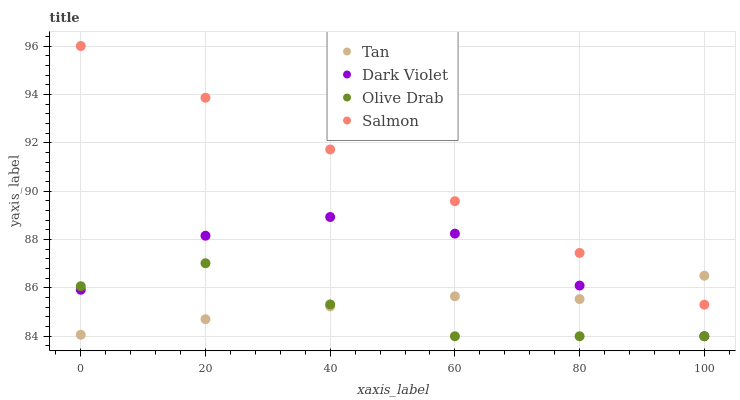Does Olive Drab have the minimum area under the curve?
Answer yes or no. Yes. Does Salmon have the maximum area under the curve?
Answer yes or no. Yes. Does Salmon have the minimum area under the curve?
Answer yes or no. No. Does Olive Drab have the maximum area under the curve?
Answer yes or no. No. Is Salmon the smoothest?
Answer yes or no. Yes. Is Dark Violet the roughest?
Answer yes or no. Yes. Is Olive Drab the smoothest?
Answer yes or no. No. Is Olive Drab the roughest?
Answer yes or no. No. Does Olive Drab have the lowest value?
Answer yes or no. Yes. Does Salmon have the lowest value?
Answer yes or no. No. Does Salmon have the highest value?
Answer yes or no. Yes. Does Olive Drab have the highest value?
Answer yes or no. No. Is Olive Drab less than Salmon?
Answer yes or no. Yes. Is Salmon greater than Olive Drab?
Answer yes or no. Yes. Does Olive Drab intersect Tan?
Answer yes or no. Yes. Is Olive Drab less than Tan?
Answer yes or no. No. Is Olive Drab greater than Tan?
Answer yes or no. No. Does Olive Drab intersect Salmon?
Answer yes or no. No. 